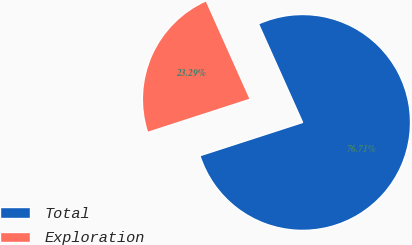Convert chart to OTSL. <chart><loc_0><loc_0><loc_500><loc_500><pie_chart><fcel>Total<fcel>Exploration<nl><fcel>76.71%<fcel>23.29%<nl></chart> 